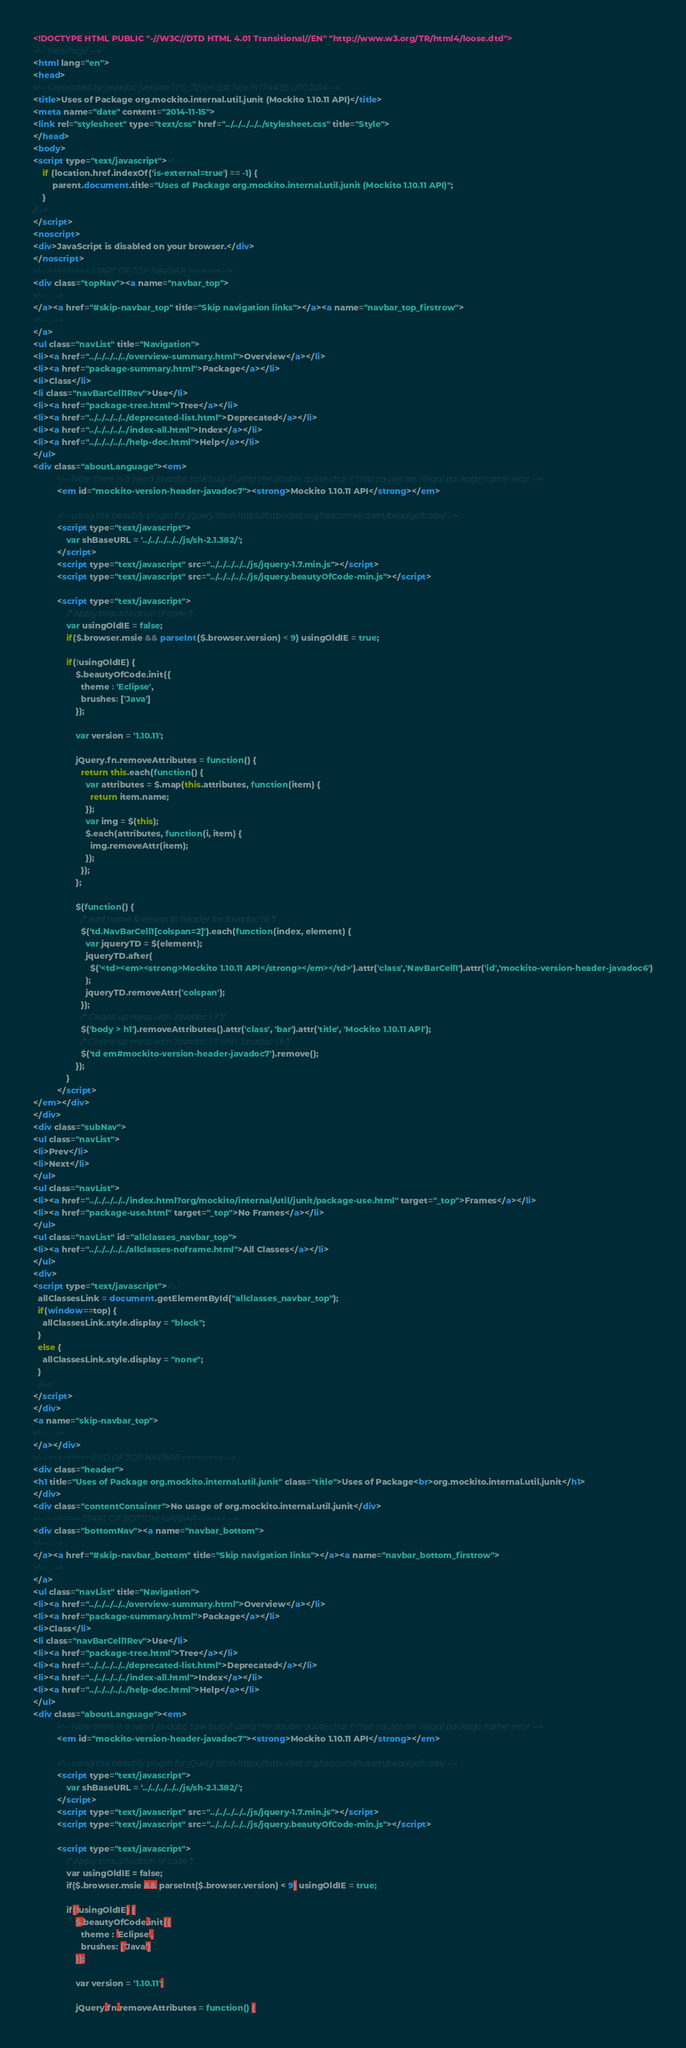Convert code to text. <code><loc_0><loc_0><loc_500><loc_500><_HTML_><!DOCTYPE HTML PUBLIC "-//W3C//DTD HTML 4.01 Transitional//EN" "http://www.w3.org/TR/html4/loose.dtd">
<!-- NewPage -->
<html lang="en">
<head>
<!-- Generated by javadoc (version 1.7.0_72) on Sat Nov 15 17:44:55 UTC 2014 -->
<title>Uses of Package org.mockito.internal.util.junit (Mockito 1.10.11 API)</title>
<meta name="date" content="2014-11-15">
<link rel="stylesheet" type="text/css" href="../../../../../stylesheet.css" title="Style">
</head>
<body>
<script type="text/javascript"><!--
    if (location.href.indexOf('is-external=true') == -1) {
        parent.document.title="Uses of Package org.mockito.internal.util.junit (Mockito 1.10.11 API)";
    }
//-->
</script>
<noscript>
<div>JavaScript is disabled on your browser.</div>
</noscript>
<!-- ========= START OF TOP NAVBAR ======= -->
<div class="topNav"><a name="navbar_top">
<!--   -->
</a><a href="#skip-navbar_top" title="Skip navigation links"></a><a name="navbar_top_firstrow">
<!--   -->
</a>
<ul class="navList" title="Navigation">
<li><a href="../../../../../overview-summary.html">Overview</a></li>
<li><a href="package-summary.html">Package</a></li>
<li>Class</li>
<li class="navBarCell1Rev">Use</li>
<li><a href="package-tree.html">Tree</a></li>
<li><a href="../../../../../deprecated-list.html">Deprecated</a></li>
<li><a href="../../../../../index-all.html">Index</a></li>
<li><a href="../../../../../help-doc.html">Help</a></li>
</ul>
<div class="aboutLanguage"><em>
          <!-- Note there is a weird javadoc task bug if using the double quote char \" that causes an 'illegal package name' error -->
          <em id="mockito-version-header-javadoc7"><strong>Mockito 1.10.11 API</strong></em>

          <!-- using the beautify plugin for jQuery from https://bitbucket.org/larscorneliussen/beautyofcode/ -->
          <script type="text/javascript">
              var shBaseURL = '../../../../../js/sh-2.1.382/';
          </script>
          <script type="text/javascript" src="../../../../../js/jquery-1.7.min.js"></script>
          <script type="text/javascript" src="../../../../../js/jquery.beautyOfCode-min.js"></script>

          <script type="text/javascript">
              /* Apply beautification of code */
              var usingOldIE = false;
              if($.browser.msie && parseInt($.browser.version) < 9) usingOldIE = true;

              if(!usingOldIE) {
                  $.beautyOfCode.init({
                    theme : 'Eclipse',
                    brushes: ['Java']
                  });

                  var version = '1.10.11';

                  jQuery.fn.removeAttributes = function() {
                    return this.each(function() {
                      var attributes = $.map(this.attributes, function(item) {
                        return item.name;
                      });
                      var img = $(this);
                      $.each(attributes, function(i, item) {
                        img.removeAttr(item);
                      });
                    });
                  };

                  $(function() {
                    /* Add name & version to header for Javadoc 1.6 */
                    $('td.NavBarCell1[colspan=2]').each(function(index, element) {
                      var jqueryTD = $(element);
                      jqueryTD.after(
                        $('<td><em><strong>Mockito 1.10.11 API</strong></em></td>').attr('class','NavBarCell1').attr('id','mockito-version-header-javadoc6')
                      );
                      jqueryTD.removeAttr('colspan');
                    });
                    /* Cleans up mess with Javadoc 1.7 */
                    $('body > h1').removeAttributes().attr('class', 'bar').attr('title', 'Mockito 1.10.11 API');
                    /* Cleans up mess with Javadoc 1.7 with Javadoc 1.6 */
                    $('td em#mockito-version-header-javadoc7').remove();
                  });
              }
          </script>
</em></div>
</div>
<div class="subNav">
<ul class="navList">
<li>Prev</li>
<li>Next</li>
</ul>
<ul class="navList">
<li><a href="../../../../../index.html?org/mockito/internal/util/junit/package-use.html" target="_top">Frames</a></li>
<li><a href="package-use.html" target="_top">No Frames</a></li>
</ul>
<ul class="navList" id="allclasses_navbar_top">
<li><a href="../../../../../allclasses-noframe.html">All Classes</a></li>
</ul>
<div>
<script type="text/javascript"><!--
  allClassesLink = document.getElementById("allclasses_navbar_top");
  if(window==top) {
    allClassesLink.style.display = "block";
  }
  else {
    allClassesLink.style.display = "none";
  }
  //-->
</script>
</div>
<a name="skip-navbar_top">
<!--   -->
</a></div>
<!-- ========= END OF TOP NAVBAR ========= -->
<div class="header">
<h1 title="Uses of Package org.mockito.internal.util.junit" class="title">Uses of Package<br>org.mockito.internal.util.junit</h1>
</div>
<div class="contentContainer">No usage of org.mockito.internal.util.junit</div>
<!-- ======= START OF BOTTOM NAVBAR ====== -->
<div class="bottomNav"><a name="navbar_bottom">
<!--   -->
</a><a href="#skip-navbar_bottom" title="Skip navigation links"></a><a name="navbar_bottom_firstrow">
<!--   -->
</a>
<ul class="navList" title="Navigation">
<li><a href="../../../../../overview-summary.html">Overview</a></li>
<li><a href="package-summary.html">Package</a></li>
<li>Class</li>
<li class="navBarCell1Rev">Use</li>
<li><a href="package-tree.html">Tree</a></li>
<li><a href="../../../../../deprecated-list.html">Deprecated</a></li>
<li><a href="../../../../../index-all.html">Index</a></li>
<li><a href="../../../../../help-doc.html">Help</a></li>
</ul>
<div class="aboutLanguage"><em>
          <!-- Note there is a weird javadoc task bug if using the double quote char \" that causes an 'illegal package name' error -->
          <em id="mockito-version-header-javadoc7"><strong>Mockito 1.10.11 API</strong></em>

          <!-- using the beautify plugin for jQuery from https://bitbucket.org/larscorneliussen/beautyofcode/ -->
          <script type="text/javascript">
              var shBaseURL = '../../../../../js/sh-2.1.382/';
          </script>
          <script type="text/javascript" src="../../../../../js/jquery-1.7.min.js"></script>
          <script type="text/javascript" src="../../../../../js/jquery.beautyOfCode-min.js"></script>

          <script type="text/javascript">
              /* Apply beautification of code */
              var usingOldIE = false;
              if($.browser.msie && parseInt($.browser.version) < 9) usingOldIE = true;

              if(!usingOldIE) {
                  $.beautyOfCode.init({
                    theme : 'Eclipse',
                    brushes: ['Java']
                  });

                  var version = '1.10.11';

                  jQuery.fn.removeAttributes = function() {</code> 